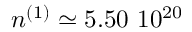Convert formula to latex. <formula><loc_0><loc_0><loc_500><loc_500>n ^ { ( 1 ) } \simeq 5 . 5 0 \ 1 0 ^ { 2 0 }</formula> 